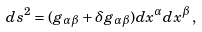Convert formula to latex. <formula><loc_0><loc_0><loc_500><loc_500>d s ^ { 2 } = ( g _ { \alpha \beta } + \delta g _ { \alpha \beta } ) d x ^ { \alpha } d x ^ { \beta } \, ,</formula> 